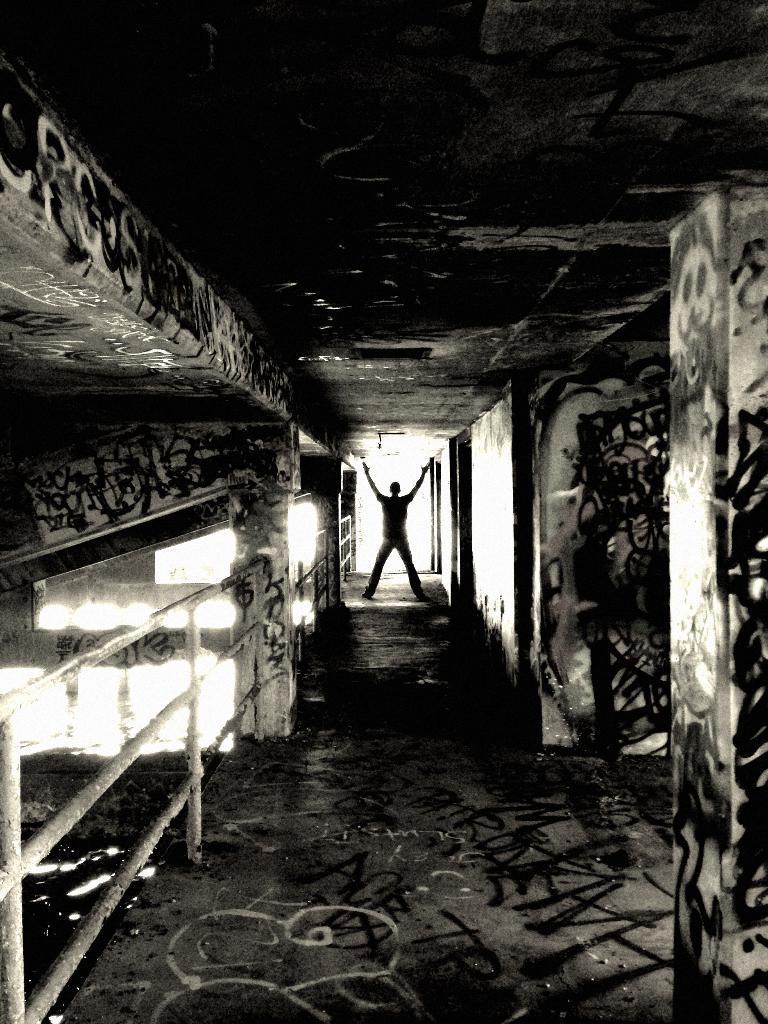How would you summarize this image in a sentence or two? There is a person standing and we can see wall and floor. 